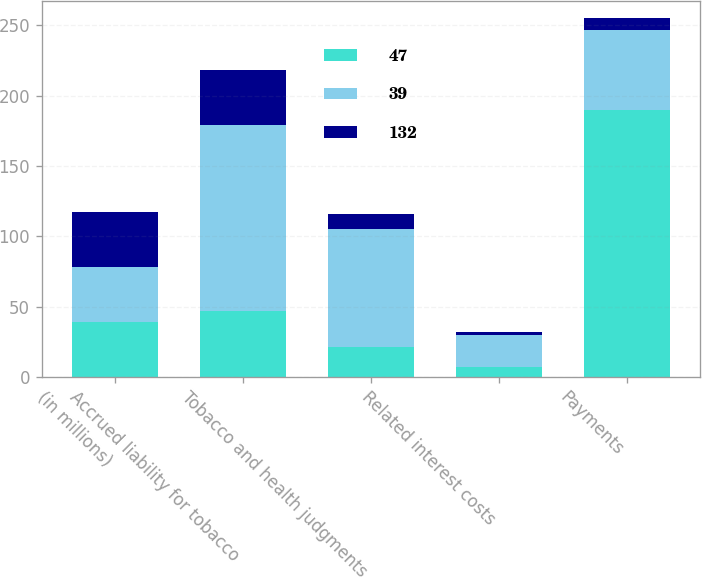Convert chart. <chart><loc_0><loc_0><loc_500><loc_500><stacked_bar_chart><ecel><fcel>(in millions)<fcel>Accrued liability for tobacco<fcel>Tobacco and health judgments<fcel>Related interest costs<fcel>Payments<nl><fcel>47<fcel>39<fcel>47<fcel>21<fcel>7<fcel>190<nl><fcel>39<fcel>39<fcel>132<fcel>84<fcel>23<fcel>57<nl><fcel>132<fcel>39<fcel>39<fcel>11<fcel>2<fcel>8<nl></chart> 